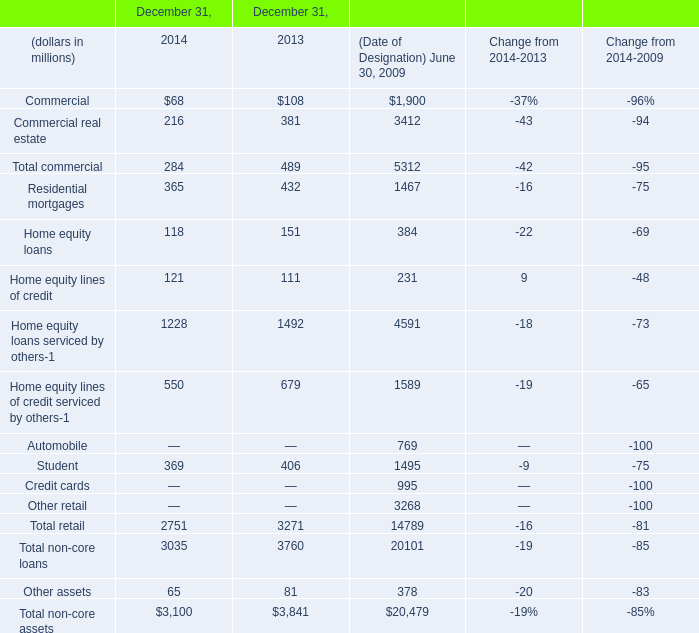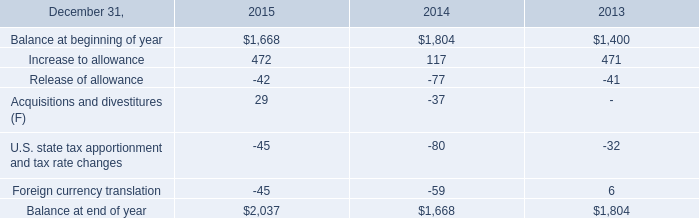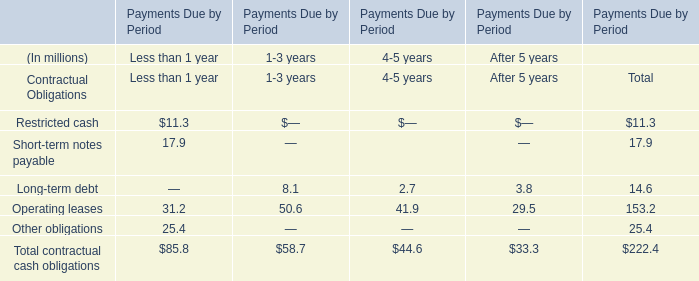Does the value of Home equity loans in 2014 greater than that in 2013? 
Answer: no. 